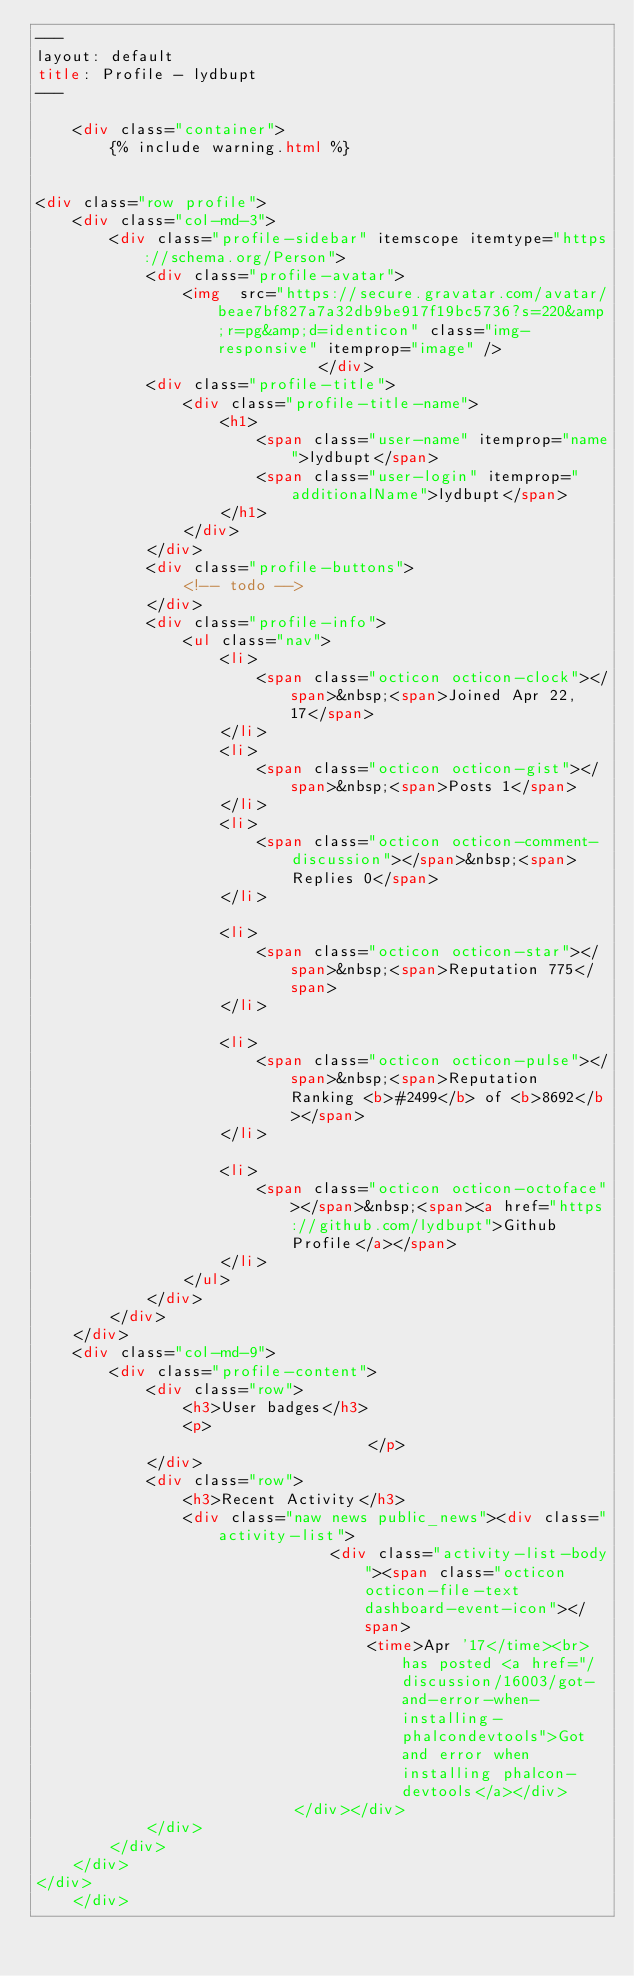<code> <loc_0><loc_0><loc_500><loc_500><_HTML_>---
layout: default
title: Profile - lydbupt
---

    <div class="container">
        {% include warning.html %}


<div class="row profile">
    <div class="col-md-3">
        <div class="profile-sidebar" itemscope itemtype="https://schema.org/Person">
            <div class="profile-avatar">
                <img  src="https://secure.gravatar.com/avatar/beae7bf827a7a32db9be917f19bc5736?s=220&amp;r=pg&amp;d=identicon" class="img-responsive" itemprop="image" />            </div>
            <div class="profile-title">
                <div class="profile-title-name">
                    <h1>
                        <span class="user-name" itemprop="name">lydbupt</span>
                        <span class="user-login" itemprop="additionalName">lydbupt</span>
                    </h1>
                </div>
            </div>
            <div class="profile-buttons">
                <!-- todo -->
            </div>
            <div class="profile-info">
                <ul class="nav">
                    <li>
                        <span class="octicon octicon-clock"></span>&nbsp;<span>Joined Apr 22, 17</span>
                    </li>
                    <li>
                        <span class="octicon octicon-gist"></span>&nbsp;<span>Posts 1</span>
                    </li>
                    <li>
                        <span class="octicon octicon-comment-discussion"></span>&nbsp;<span>Replies 0</span>
                    </li>

                    <li>
                        <span class="octicon octicon-star"></span>&nbsp;<span>Reputation 775</span>
                    </li>

                    <li>
                        <span class="octicon octicon-pulse"></span>&nbsp;<span>Reputation Ranking <b>#2499</b> of <b>8692</b></span>
                    </li>

                    <li>
                        <span class="octicon octicon-octoface"></span>&nbsp;<span><a href="https://github.com/lydbupt">Github Profile</a></span>
                    </li>
                </ul>
            </div>
        </div>
    </div>
    <div class="col-md-9">
        <div class="profile-content">
            <div class="row">
                <h3>User badges</h3>
                <p>
                                    </p>
            </div>
            <div class="row">
                <h3>Recent Activity</h3>
                <div class="naw news public_news"><div class="activity-list">
                                <div class="activity-list-body"><span class="octicon octicon-file-text dashboard-event-icon"></span>
                                    <time>Apr '17</time><br>has posted <a href="/discussion/16003/got-and-error-when-installing-phalcondevtools">Got and error when installing phalcon-devtools</a></div>
                            </div></div>
            </div>
        </div>
    </div>
</div>
    </div>

    

</code> 